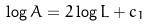<formula> <loc_0><loc_0><loc_500><loc_500>\log A = 2 \log L + c _ { 1 }</formula> 